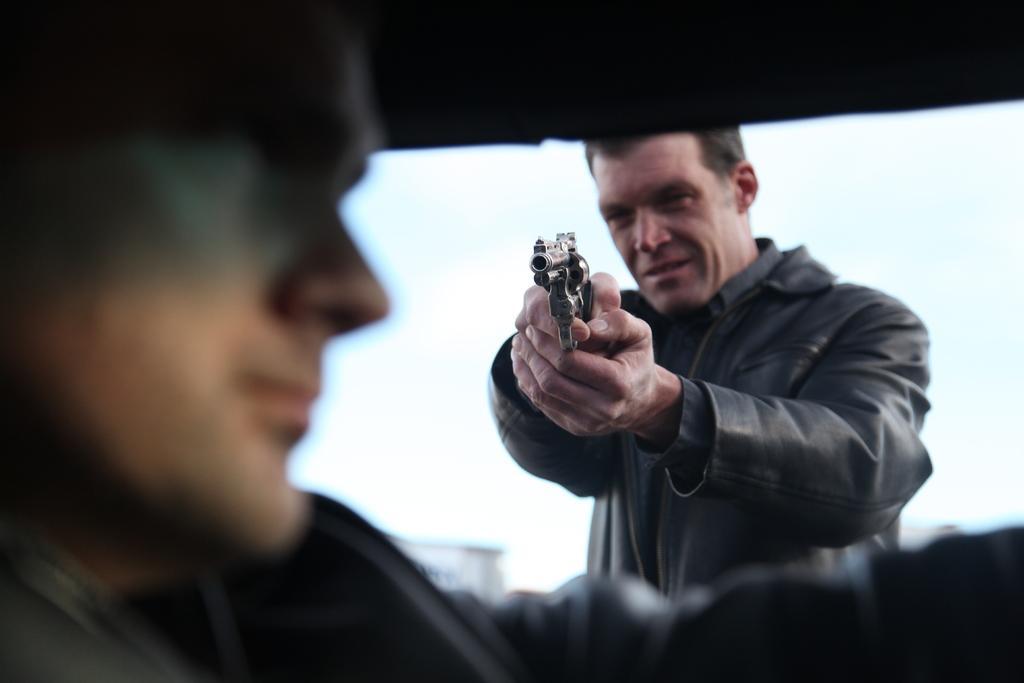Please provide a concise description of this image. In this image we can see a person holding a gun and pointing at another person. 